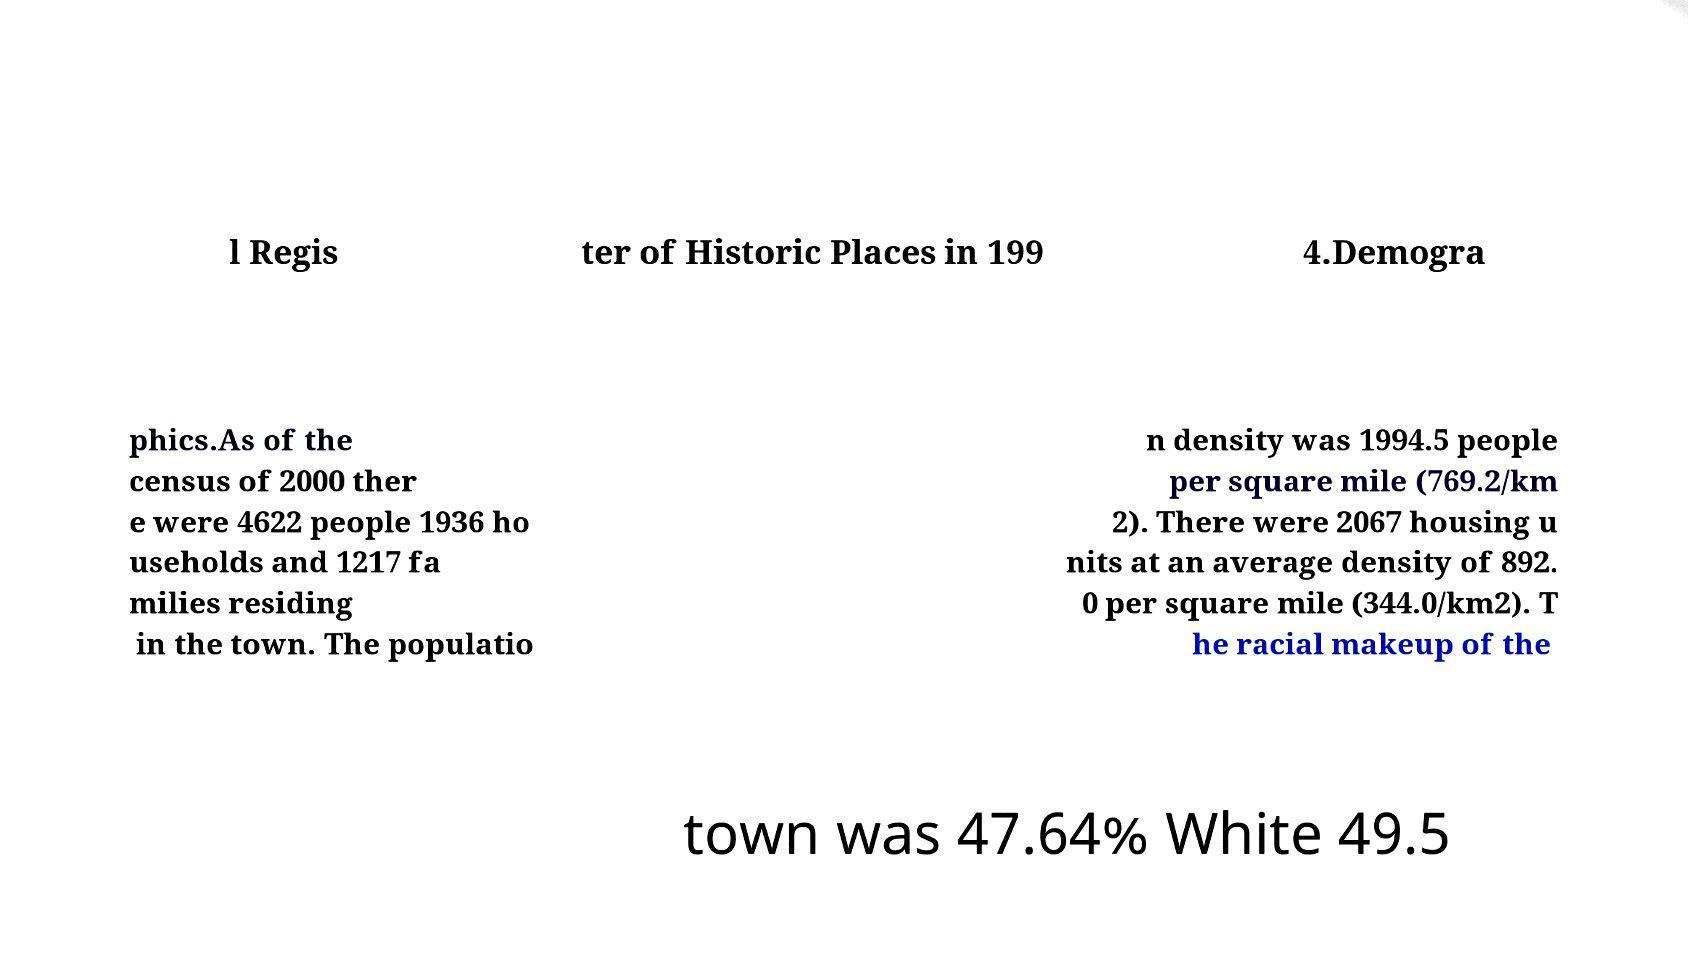For documentation purposes, I need the text within this image transcribed. Could you provide that? l Regis ter of Historic Places in 199 4.Demogra phics.As of the census of 2000 ther e were 4622 people 1936 ho useholds and 1217 fa milies residing in the town. The populatio n density was 1994.5 people per square mile (769.2/km 2). There were 2067 housing u nits at an average density of 892. 0 per square mile (344.0/km2). T he racial makeup of the town was 47.64% White 49.5 